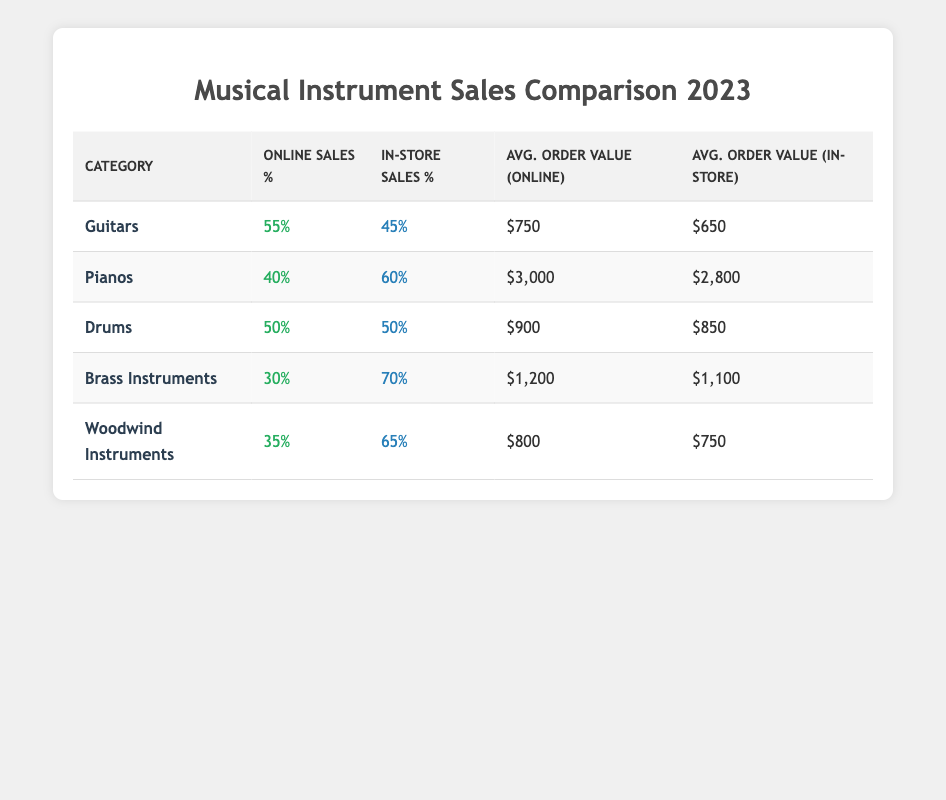What percentage of sales for guitars were made online? The table shows that online sales for guitars are 55%.
Answer: 55% What is the average order value for pianos sold in-store? The table indicates that the average order value for pianos sold in-store is $2,800.
Answer: $2,800 How much higher is the average order value for online sales of brass instruments compared to in-store sales? The average order value for online sales of brass instruments is $1,200 and in-store it is $1,100. The difference is $1,200 - $1,100 = $100.
Answer: $100 Which category has the highest percentage of in-store sales? By comparing the in-store sales percentages, pianos have 60%, which is the highest among all categories.
Answer: Pianos Are online sales for woodwind instruments greater than for brass instruments? The online sales percentage for woodwind instruments is 35%, while for brass instruments it is 30%. Thus, online sales for woodwinds are greater.
Answer: Yes What is the overall average online order value across all categories? To find the overall average, sum the average order values for online sales ($750, $3,000, $900, $1,200, $800) which equals $6,650. Then divide by the total number of categories (5). So, $6,650 / 5 = $1,330.
Answer: $1,330 How do the in-store sales percentages for guitars and drums compare? The in-store percentages for guitars and drums are 45% and 50%, respectively. Drums have a higher in-store sales percentage by 5%.
Answer: Drums have a higher percentage by 5% Which category has the lowest online sales percentage? The lowest online sales percentage is for brass instruments at 30%.
Answer: Brass Instruments 